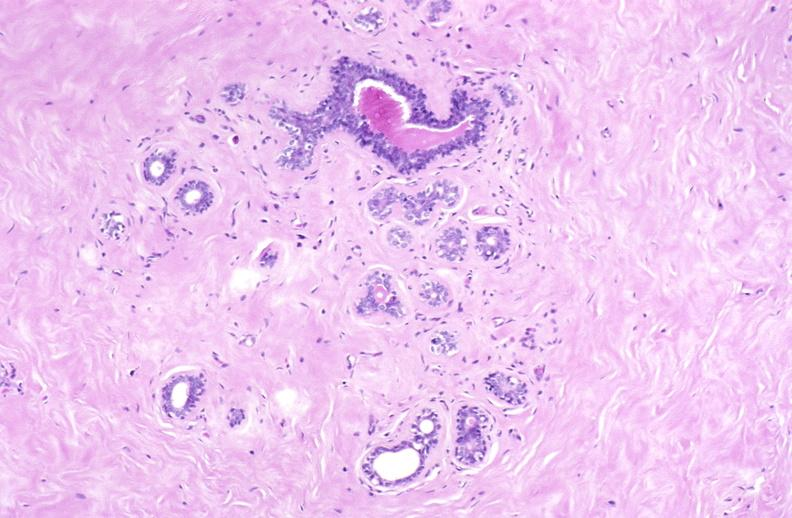does this image show breast, fibroadenoma?
Answer the question using a single word or phrase. Yes 